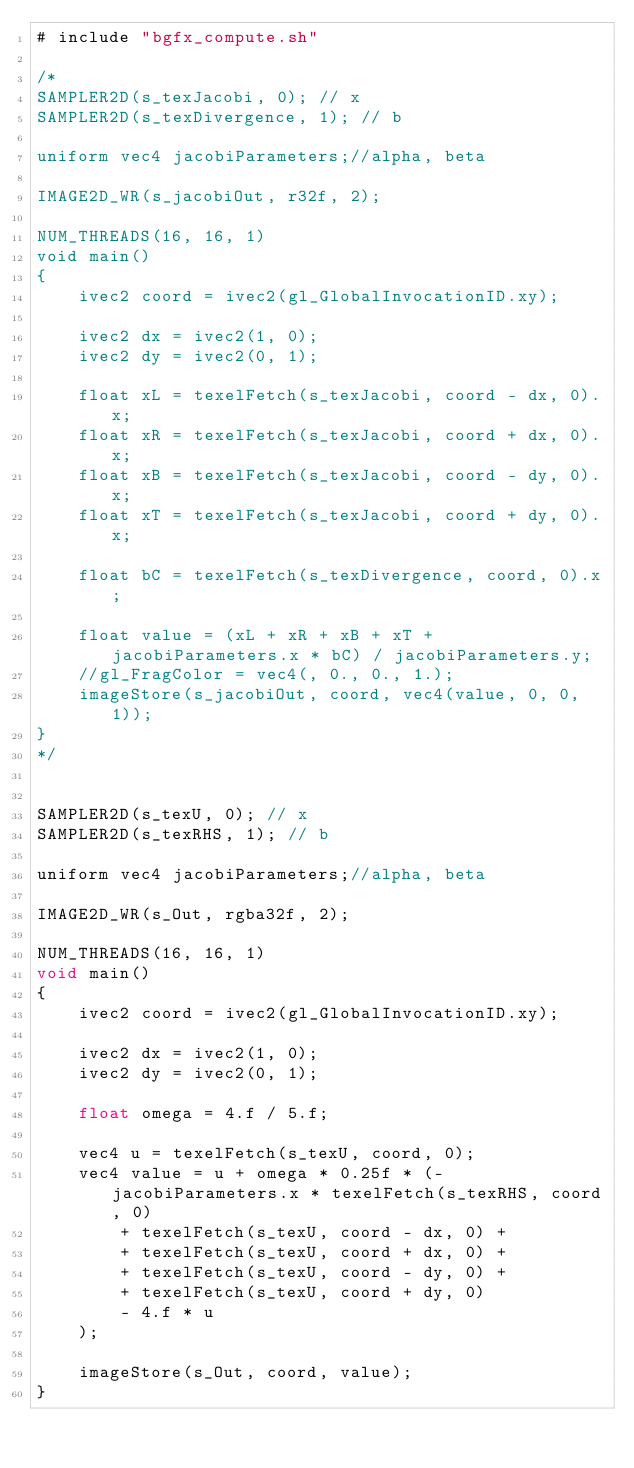<code> <loc_0><loc_0><loc_500><loc_500><_C#_># include "bgfx_compute.sh"

/*
SAMPLER2D(s_texJacobi, 0); // x
SAMPLER2D(s_texDivergence, 1); // b

uniform vec4 jacobiParameters;//alpha, beta

IMAGE2D_WR(s_jacobiOut, r32f, 2);

NUM_THREADS(16, 16, 1)
void main()
{
	ivec2 coord = ivec2(gl_GlobalInvocationID.xy);

	ivec2 dx = ivec2(1, 0);
	ivec2 dy = ivec2(0, 1);

	float xL = texelFetch(s_texJacobi, coord - dx, 0).x;
	float xR = texelFetch(s_texJacobi, coord + dx, 0).x;
	float xB = texelFetch(s_texJacobi, coord - dy, 0).x;
	float xT = texelFetch(s_texJacobi, coord + dy, 0).x;

	float bC = texelFetch(s_texDivergence, coord, 0).x;

	float value = (xL + xR + xB + xT + jacobiParameters.x * bC) / jacobiParameters.y;
	//gl_FragColor = vec4(, 0., 0., 1.);
	imageStore(s_jacobiOut, coord, vec4(value, 0, 0, 1));
}
*/


SAMPLER2D(s_texU, 0); // x
SAMPLER2D(s_texRHS, 1); // b

uniform vec4 jacobiParameters;//alpha, beta

IMAGE2D_WR(s_Out, rgba32f, 2);

NUM_THREADS(16, 16, 1)
void main()
{
	ivec2 coord = ivec2(gl_GlobalInvocationID.xy);

	ivec2 dx = ivec2(1, 0);
	ivec2 dy = ivec2(0, 1);

	float omega = 4.f / 5.f;
	
    vec4 u = texelFetch(s_texU, coord, 0);
	vec4 value = u + omega * 0.25f * (-jacobiParameters.x * texelFetch(s_texRHS, coord, 0)
		+ texelFetch(s_texU, coord - dx, 0) +
		+ texelFetch(s_texU, coord + dx, 0) +
		+ texelFetch(s_texU, coord - dy, 0) +
		+ texelFetch(s_texU, coord + dy, 0) 
		- 4.f * u
	);
 
	imageStore(s_Out, coord, value);
}
</code> 